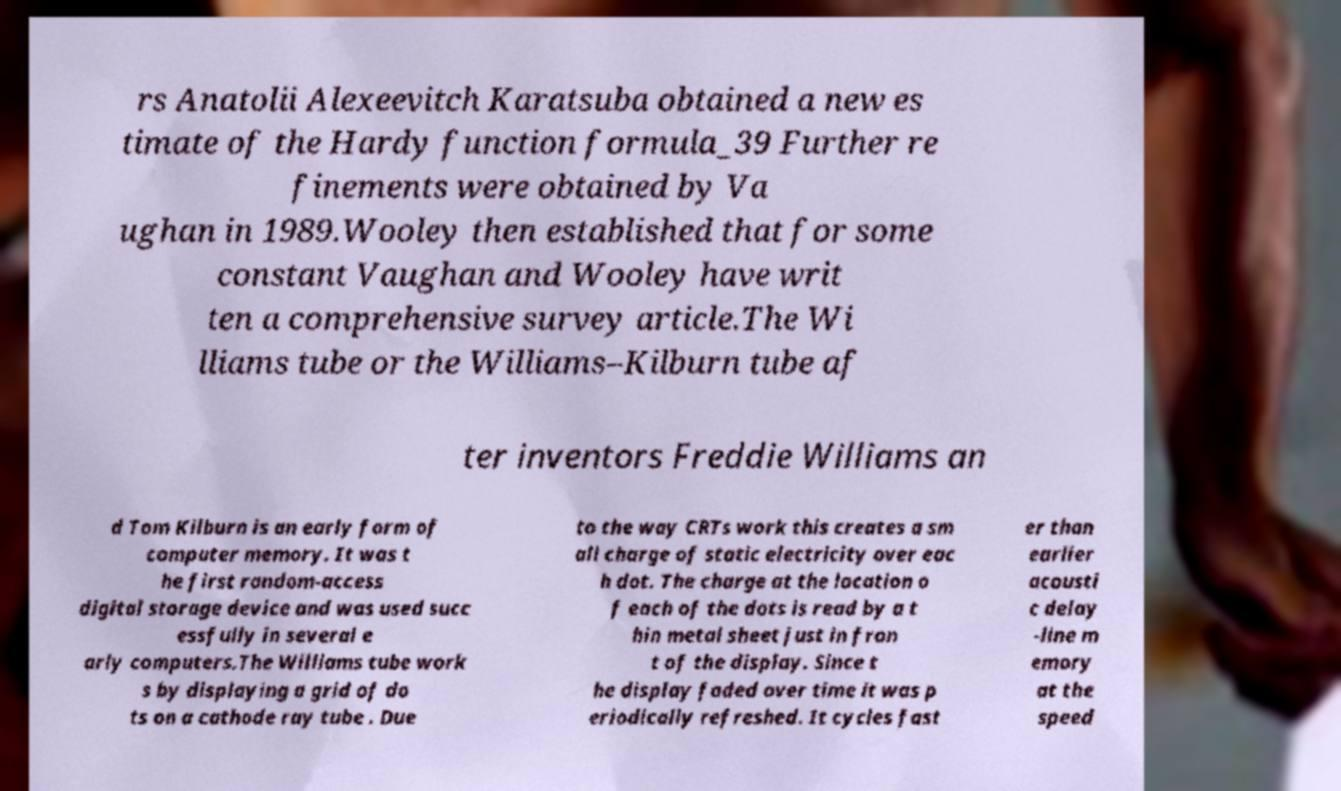Please read and relay the text visible in this image. What does it say? rs Anatolii Alexeevitch Karatsuba obtained a new es timate of the Hardy function formula_39 Further re finements were obtained by Va ughan in 1989.Wooley then established that for some constant Vaughan and Wooley have writ ten a comprehensive survey article.The Wi lliams tube or the Williams–Kilburn tube af ter inventors Freddie Williams an d Tom Kilburn is an early form of computer memory. It was t he first random-access digital storage device and was used succ essfully in several e arly computers.The Williams tube work s by displaying a grid of do ts on a cathode ray tube . Due to the way CRTs work this creates a sm all charge of static electricity over eac h dot. The charge at the location o f each of the dots is read by a t hin metal sheet just in fron t of the display. Since t he display faded over time it was p eriodically refreshed. It cycles fast er than earlier acousti c delay -line m emory at the speed 